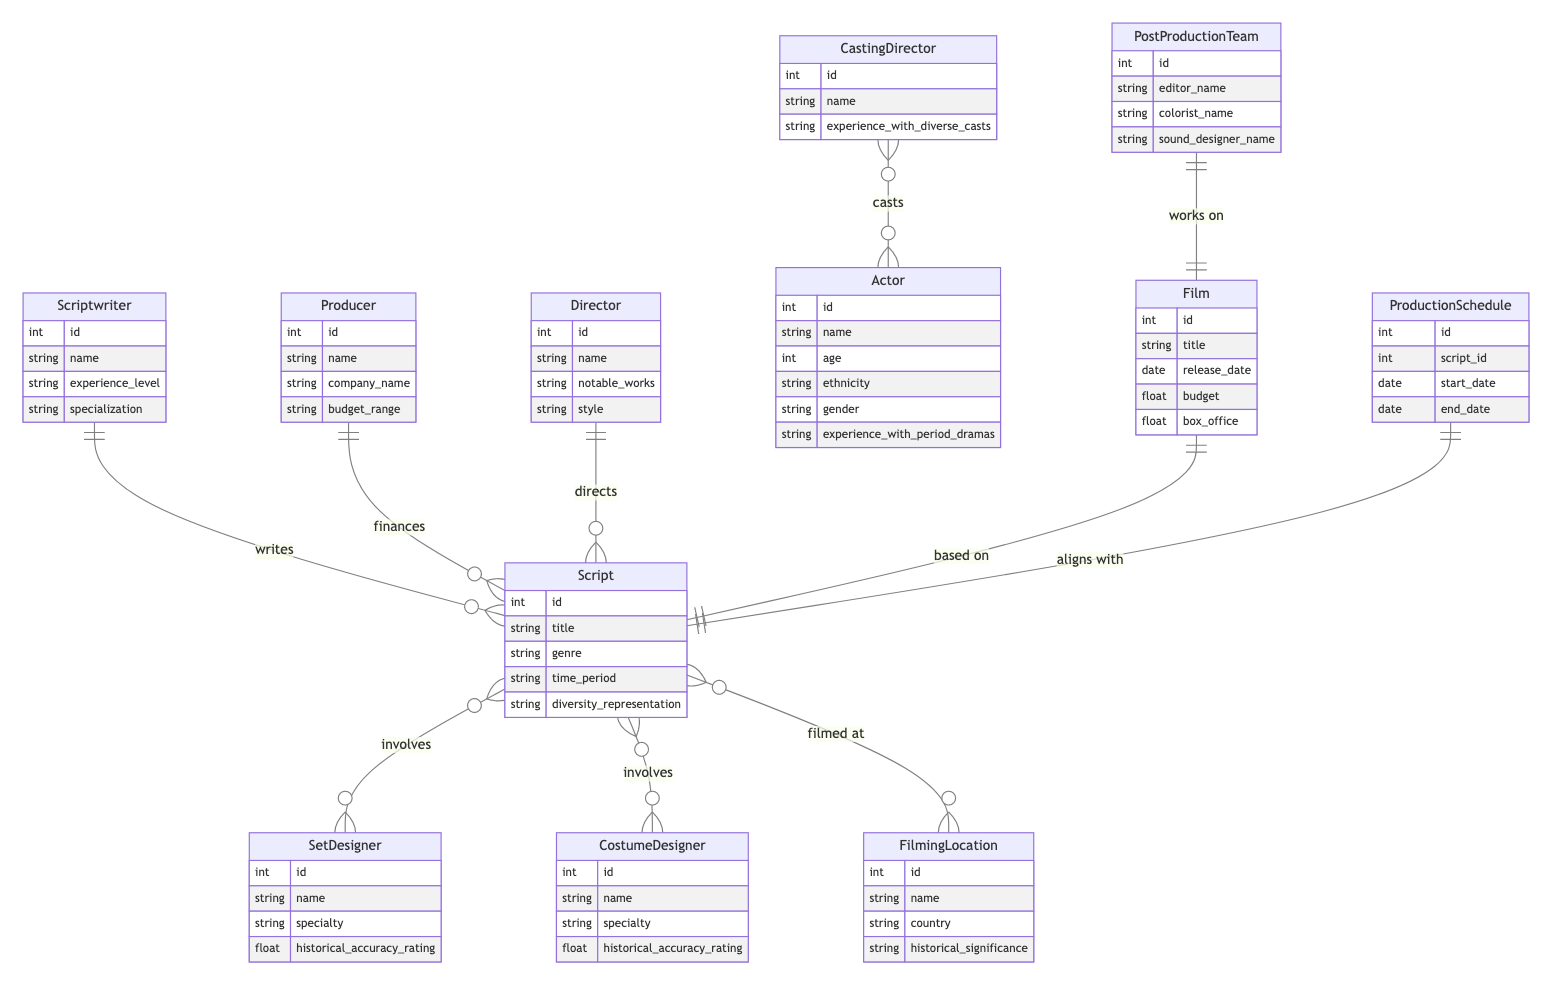What is the maximum number of actors that can be involved with a script? In the diagram, the relationship between CastingDirector and Actor is many-to-many, which means multiple actors can be cast by multiple casting directors. Therefore, there is no predefined maximum number of actors that can be associated with a script.
Answer: Many How many attributes does the Actor entity have? The Actor entity has six defined attributes: id, name, age, ethnicity, gender, and experience with period dramas. By counting each of these attributes, we arrive at the total.
Answer: Six Who finances the script? The diagram shows a one-to-many relationship between Producer and Script, indicating that one producer can finance multiple scripts. Therefore, the script is financed by a Producer.
Answer: Producer Which entity is responsible for historical accuracy in design? Both the SetDesigner and CostumeDesigner entities include the attribute "historical_accuracy_rating", indicating that they are responsible for ensuring historical accuracy in their respective designs.
Answer: SetDesigner, CostumeDesigner How many distinct roles are involved in the script production process? By examining the entities in the diagram, we identify eleven distinct roles: Scriptwriter, Producer, Director, CastingDirector, Actor, SetDesigner, CostumeDesigner, FilmingLocation, ProductionSchedule, PostProductionTeam, and Film. The sum of these roles emphasizes the complexity of the production process.
Answer: Eleven What is the relationship type between Film and Script? The diagram specifies a one-to-one relationship between Film and Script, meaning that each film is based on exactly one script and vice versa. This relationship can be directly identified in the diagram.
Answer: One-to-one What does "diversity_representation" refer to in the Script entity? The attribute "diversity_representation" in the Script entity indicates how well the narrative reflects diverse perspectives and underrepresented groups. This is crucial for authenticity in period dramas.
Answer: Diversity representation What is the commonality between SetDesigner and CostumeDesigner? Both SetDesigner and CostumeDesigner entities share the attribute "historical_accuracy_rating," indicating that both roles are evaluated based on their ability to maintain historical accuracy in their designs.
Answer: Historical accuracy rating How is the ProductionSchedule linked to the Script? The diagram depicts a one-to-one relationship between ProductionSchedule and Script, indicating that each production schedule is aligned specifically with one script and is necessary for the planning of that script.
Answer: Aligns with 